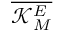Convert formula to latex. <formula><loc_0><loc_0><loc_500><loc_500>\overline { { \mathcal { K } _ { M } ^ { E } } }</formula> 